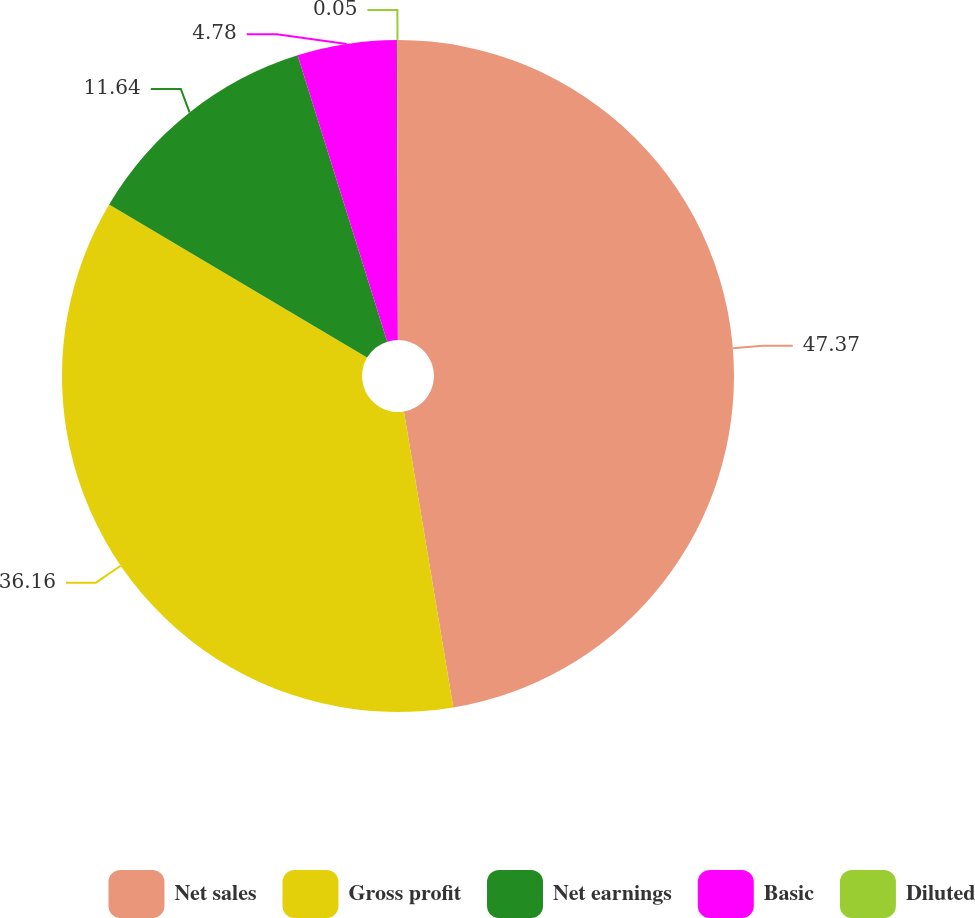Convert chart. <chart><loc_0><loc_0><loc_500><loc_500><pie_chart><fcel>Net sales<fcel>Gross profit<fcel>Net earnings<fcel>Basic<fcel>Diluted<nl><fcel>47.37%<fcel>36.16%<fcel>11.64%<fcel>4.78%<fcel>0.05%<nl></chart> 